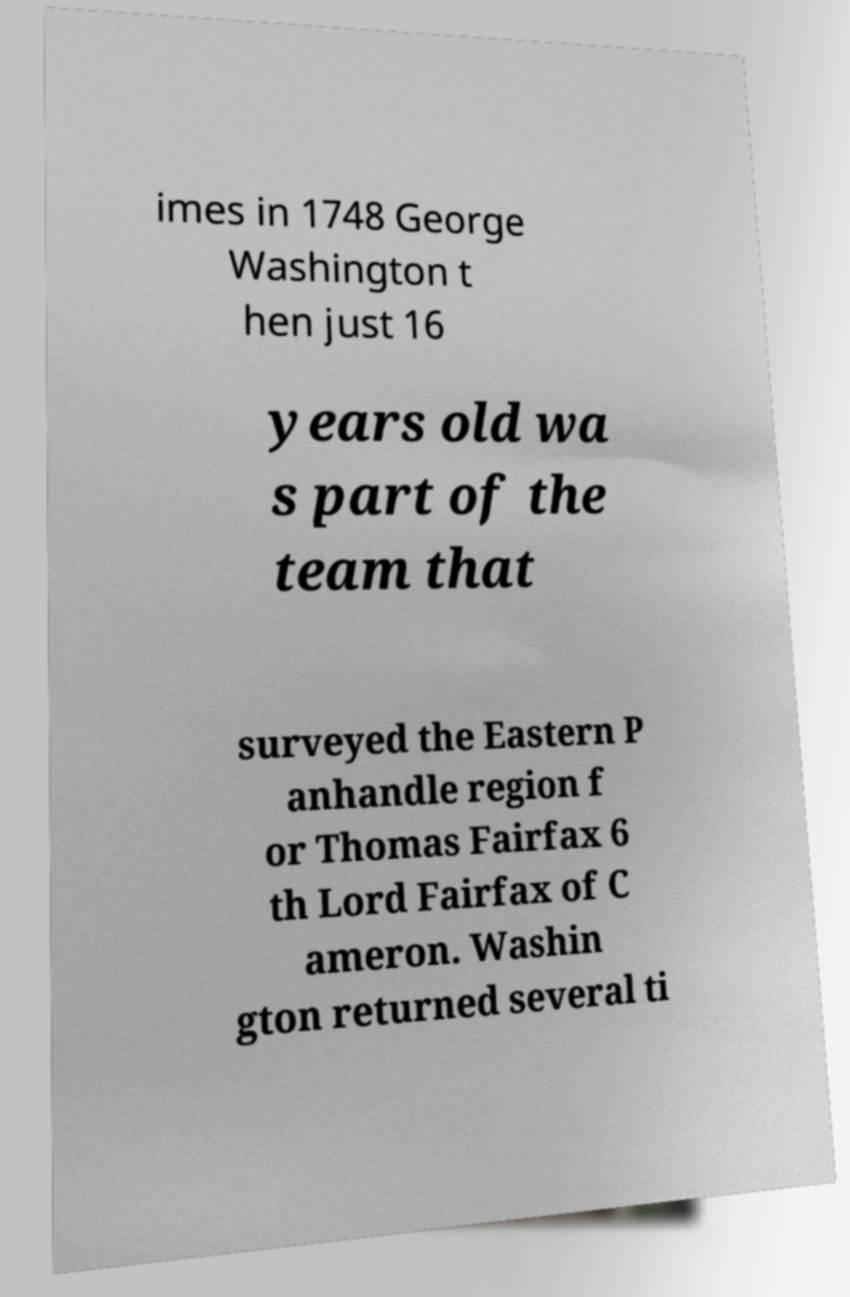Can you accurately transcribe the text from the provided image for me? imes in 1748 George Washington t hen just 16 years old wa s part of the team that surveyed the Eastern P anhandle region f or Thomas Fairfax 6 th Lord Fairfax of C ameron. Washin gton returned several ti 